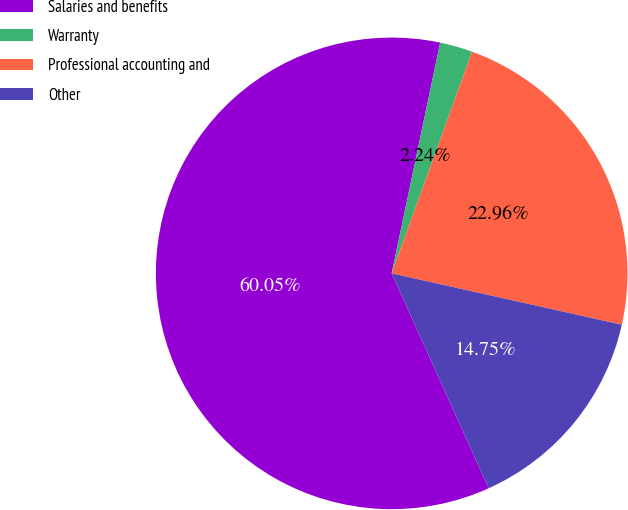Convert chart. <chart><loc_0><loc_0><loc_500><loc_500><pie_chart><fcel>Salaries and benefits<fcel>Warranty<fcel>Professional accounting and<fcel>Other<nl><fcel>60.05%<fcel>2.24%<fcel>22.96%<fcel>14.75%<nl></chart> 